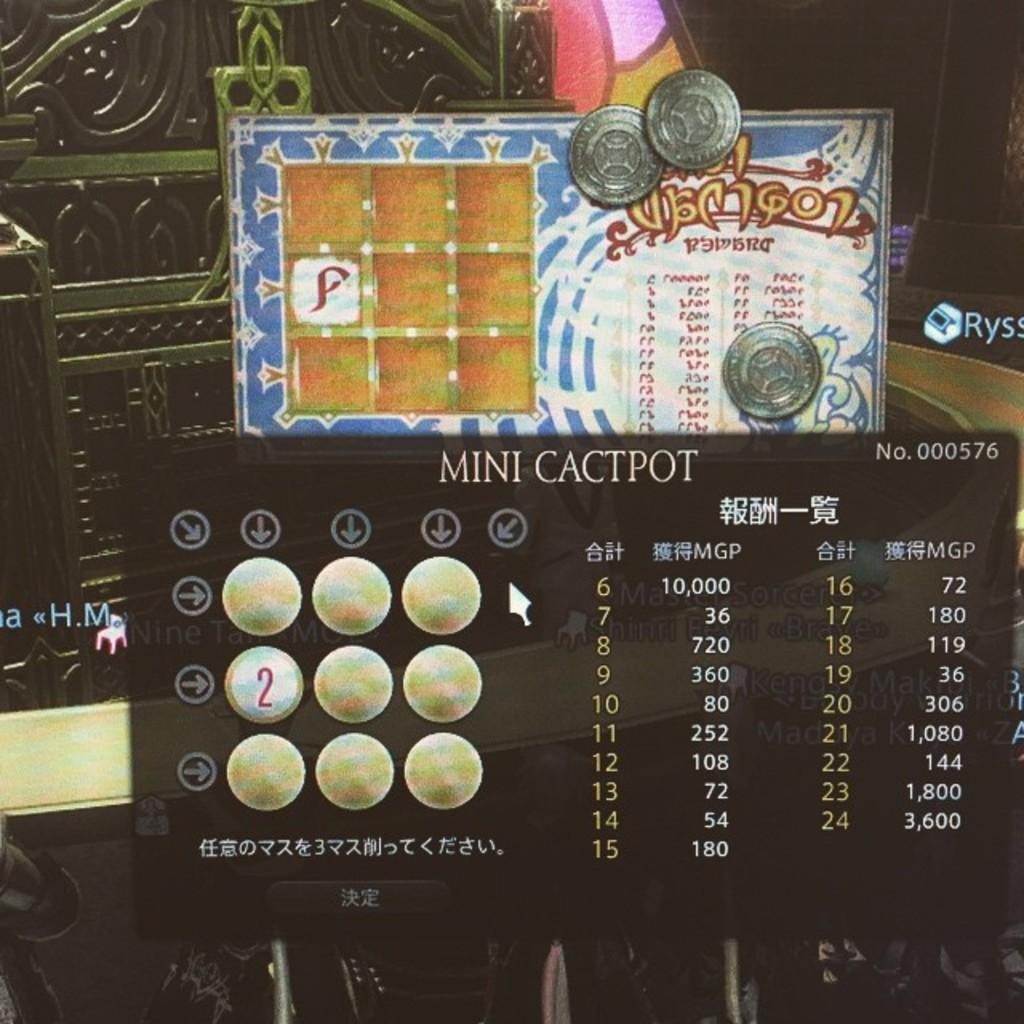Provide a one-sentence caption for the provided image. A called Mini Cactpot is on display on a screen. 